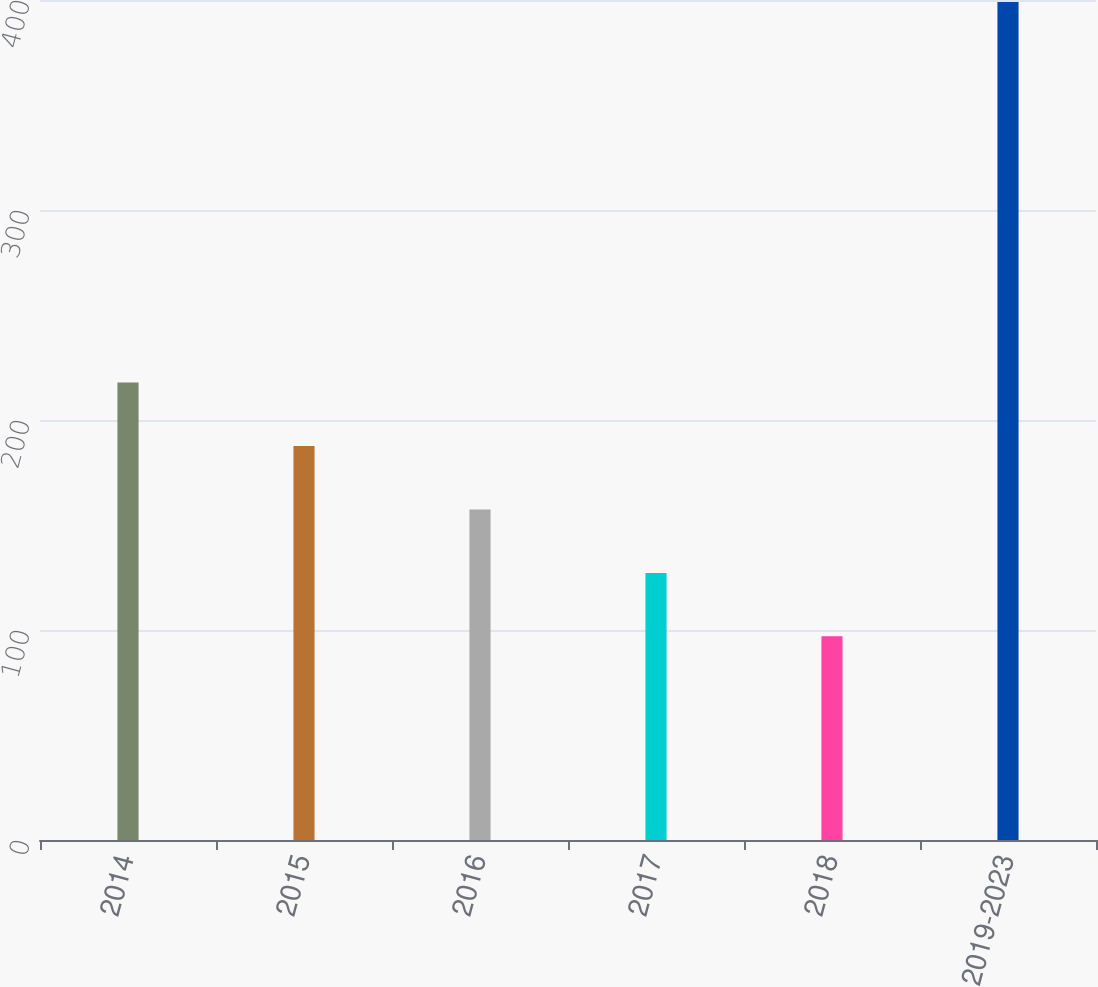Convert chart. <chart><loc_0><loc_0><loc_500><loc_500><bar_chart><fcel>2014<fcel>2015<fcel>2016<fcel>2017<fcel>2018<fcel>2019-2023<nl><fcel>217.8<fcel>187.6<fcel>157.4<fcel>127.2<fcel>97<fcel>399<nl></chart> 